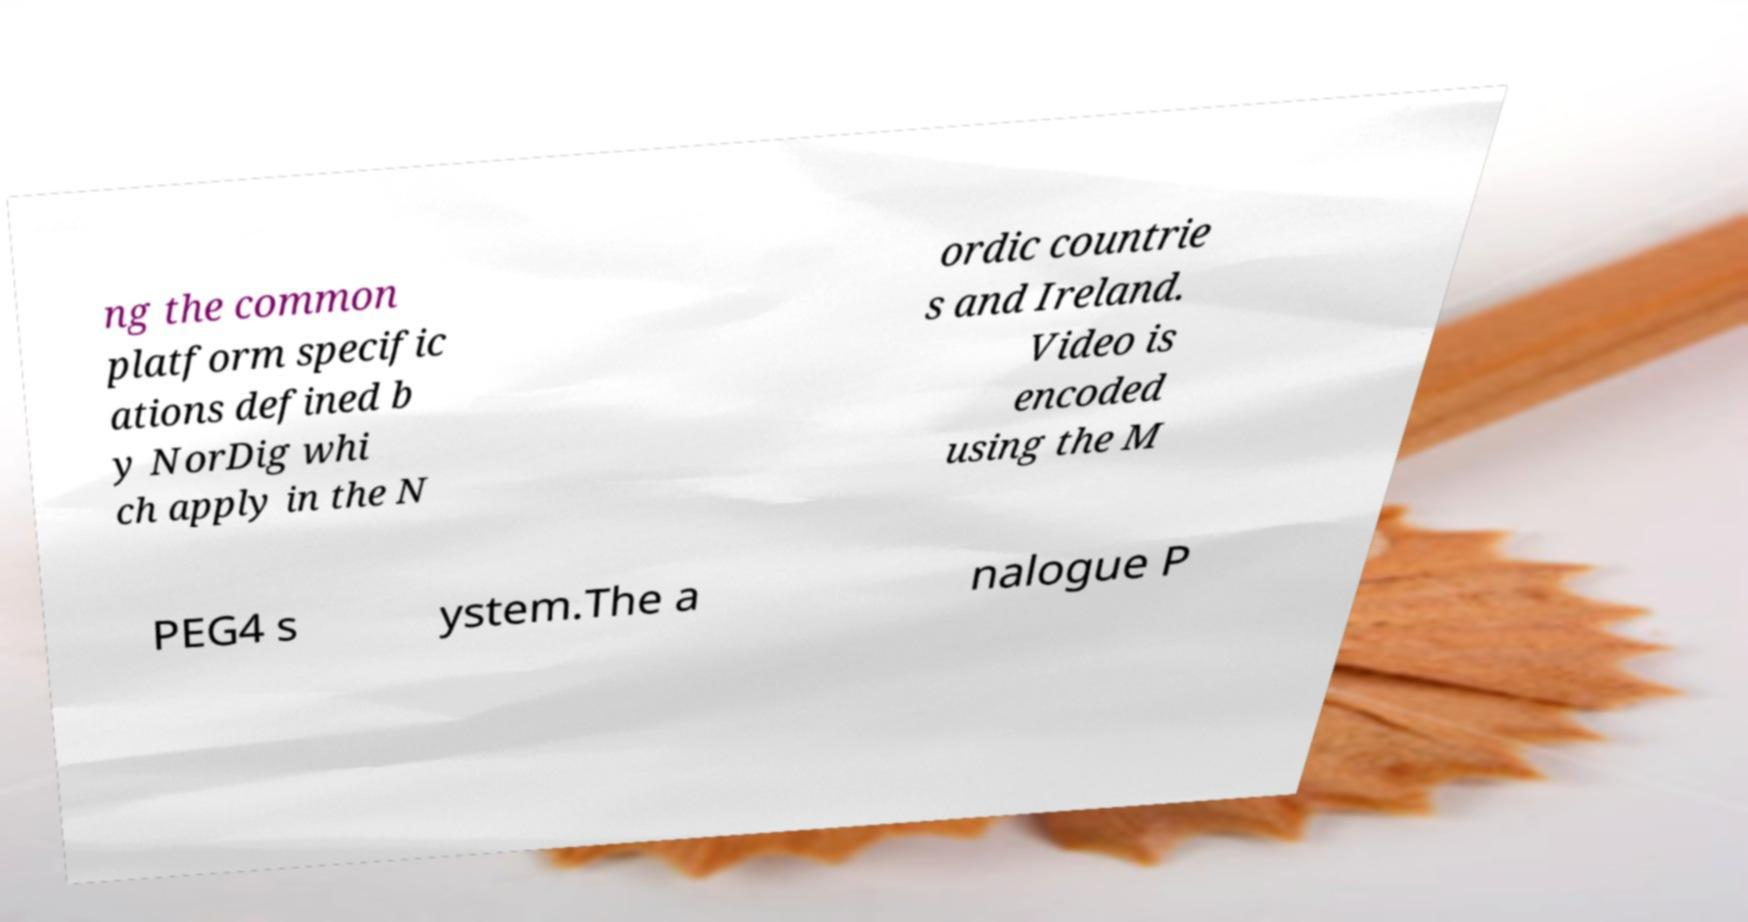Can you accurately transcribe the text from the provided image for me? ng the common platform specific ations defined b y NorDig whi ch apply in the N ordic countrie s and Ireland. Video is encoded using the M PEG4 s ystem.The a nalogue P 